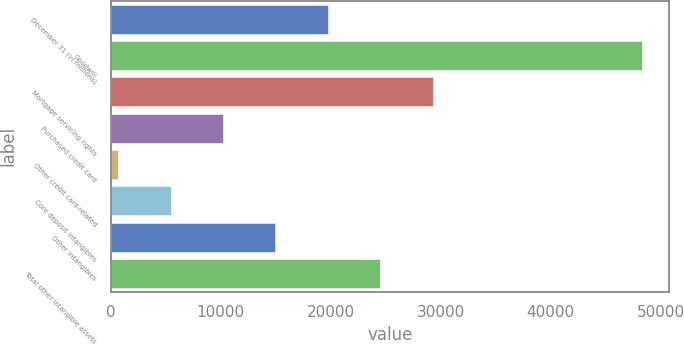<chart> <loc_0><loc_0><loc_500><loc_500><bar_chart><fcel>December 31 (in millions)<fcel>Goodwill<fcel>Mortgage servicing rights<fcel>Purchased credit card<fcel>Other credit card-related<fcel>Core deposit intangibles<fcel>Other intangibles<fcel>Total other intangible assets<nl><fcel>19757.4<fcel>48357<fcel>29290.6<fcel>10224.2<fcel>691<fcel>5457.6<fcel>14990.8<fcel>24524<nl></chart> 